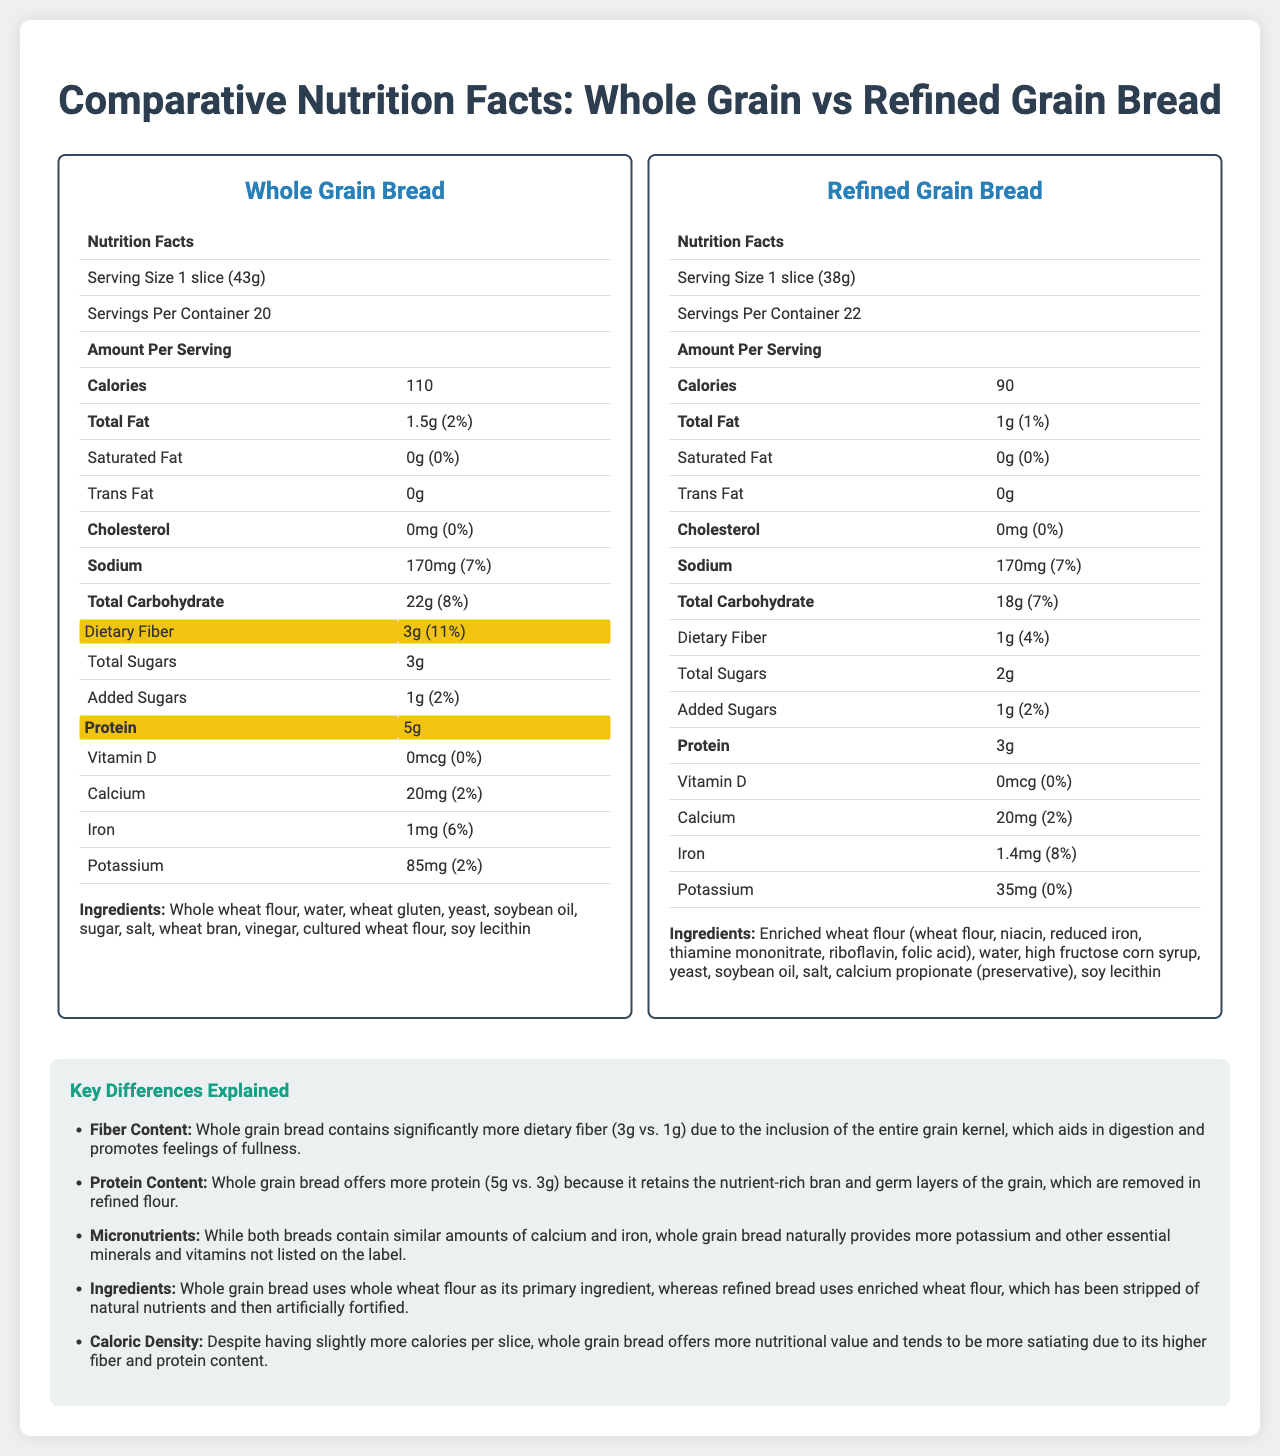what is the serving size for Whole Grain Bread? The serving size for Whole Grain Bread is explicitly stated as "1 slice (43g)" in the nutrition label for Whole Grain Bread.
Answer: 1 slice (43g) How much total carbohydrate does Refined Grain Bread provide per serving? The nutrition label for Refined Grain Bread indicates that it provides 18g of total carbohydrate per serving.
Answer: 18g What is the main difference in fiber content between Whole Grain Bread and Refined Grain Bread? According to the comparative nutrition facts, Whole Grain Bread has 3g of dietary fiber, which is significantly higher compared to the 1g in Refined Grain Bread.
Answer: Whole Grain Bread contains 3g of dietary fiber while Refined Grain Bread contains 1g. Which bread has higher protein content, and by how much? Whole Grain Bread contains 5g of protein, whereas Refined Grain Bread contains 3g. Therefore, Whole Grain Bread has 2g more protein.
Answer: Whole Grain Bread has more protein by 2g (5g vs 3g). What ingredients are listed for Refined Grain Bread? The ingredients list for Refined Grain Bread includes enriched wheat flour, water, high fructose corn syrup, yeast, soybean oil, salt, calcium propionate (preservative), soy lecithin.
Answer: Enriched wheat flour, water, high fructose corn syrup, yeast, soybean oil, salt, calcium propionate, soy lecithin Which bread product contains more calories per serving? A. Whole Grain Bread B. Refined Grain Bread Whole Grain Bread contains 110 calories per serving, while Refined Grain Bread contains 90 calories per serving.
Answer: A Which of the following is NOT an ingredient in Whole Grain Bread? i. Soybean oil ii. High fructose corn syrup iii. Wheat gluten iv. Vinegar The ingredients list for Whole Grain Bread does not include high fructose corn syrup, whereas it does include soybean oil, wheat gluten, and vinegar.
Answer: ii Does Refined Grain Bread contain any trans fat? The nutrition label for Refined Grain Bread indicates that it contains 0g of trans fat.
Answer: No Summarize the main differences highlighted between Whole Grain and Refined Grain Bread. The document highlights that Whole Grain Bread has higher fiber and protein content due to its use of whole wheat flour, making it more nutritious and filling despite having more calories. Refined Grain Bread uses enriched wheat flour, offering fewer calories per serving.
Answer: Whole Grain Bread is higher in fiber and protein, uses whole wheat flour, and has more calories per serving, making it more nutritious and satiating. Refined Grain Bread uses enriched wheat flour and contains fewer calories per serving. What is the daily value percentage of iron provided by Refined Grain Bread? The nutrition label for Refined Grain Bread shows that it provides 1.4mg of iron, which corresponds to 8% of the daily value.
Answer: 8% Which bread has more potassium content per serving, and what is the amount? According to the nutrition labels, Whole Grain Bread contains 85mg of potassium per serving, whereas Refined Grain Bread contains only 35mg.
Answer: Whole Grain Bread (85mg) What is the total fat content in Whole Grain Bread? The nutrition label for Whole Grain Bread indicates a total fat content of 1.5g per serving.
Answer: 1.5g Which bread uses enriched wheat flour as its primary ingredient? The ingredients list for Refined Grain Bread starts with enriched wheat flour as its primary ingredient.
Answer: Refined Grain Bread Can you find the exact amount of sodium in both bread types? Both the Whole Grain Bread and Refined Grain Bread contain 170mg of sodium per serving as indicated in their respective nutrition labels.
Answer: 170mg in each Which bread product is more nutritionally balanced in terms of micronutrient content? The document explains that Whole Grain Bread naturally provides more potassium and essential minerals and vitamins, making it more nutritionally balanced compared to Refined Grain Bread.
Answer: Whole Grain Bread What is the purpose of calcium propionate in Refined Grain Bread? The document does not provide any information regarding the purpose of calcium propionate in Refined Grain Bread.
Answer: Cannot be determined 